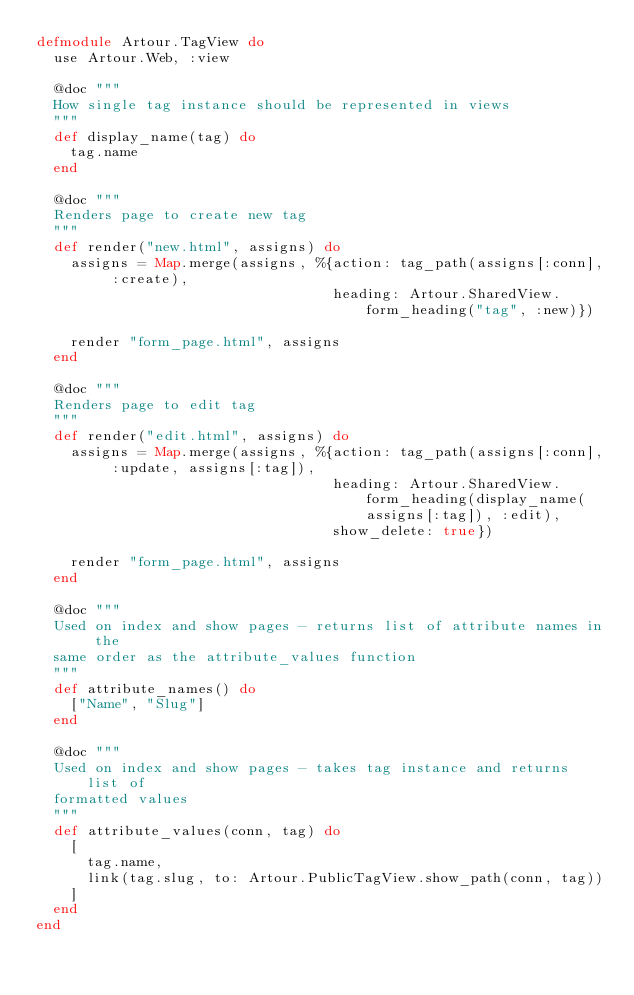Convert code to text. <code><loc_0><loc_0><loc_500><loc_500><_Elixir_>defmodule Artour.TagView do
  use Artour.Web, :view

  @doc """
  How single tag instance should be represented in views
  """
  def display_name(tag) do
    tag.name
  end

  @doc """
  Renders page to create new tag
  """
  def render("new.html", assigns) do
    assigns = Map.merge(assigns, %{action: tag_path(assigns[:conn], :create),
                                   heading: Artour.SharedView.form_heading("tag", :new)})

    render "form_page.html", assigns
  end

  @doc """
  Renders page to edit tag
  """
  def render("edit.html", assigns) do
    assigns = Map.merge(assigns, %{action: tag_path(assigns[:conn], :update, assigns[:tag]),
                                   heading: Artour.SharedView.form_heading(display_name(assigns[:tag]), :edit),
                                   show_delete: true})

    render "form_page.html", assigns
  end

  @doc """
  Used on index and show pages - returns list of attribute names in the
  same order as the attribute_values function
  """
  def attribute_names() do
    ["Name", "Slug"]
  end

  @doc """
  Used on index and show pages - takes tag instance and returns list of 
  formatted values
  """
  def attribute_values(conn, tag) do
  	[
      tag.name, 
      link(tag.slug, to: Artour.PublicTagView.show_path(conn, tag))
    ]
  end
end
</code> 